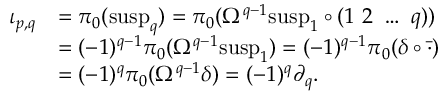Convert formula to latex. <formula><loc_0><loc_0><loc_500><loc_500>\begin{array} { r l } { \iota _ { p , q } } & { = \pi _ { 0 } ( s u s p _ { q } ) = \pi _ { 0 } ( \Omega ^ { q - 1 } s u s p _ { 1 } \circ ( 1 \ 2 \ \dots \ q ) ) } \\ & { = ( - 1 ) ^ { q - 1 } \pi _ { 0 } ( \Omega ^ { q - 1 } s u s p _ { 1 } ) = ( - 1 ) ^ { q - 1 } \pi _ { 0 } ( \delta \circ \ B a r { \cdot } ) } \\ & { = ( - 1 ) ^ { q } \pi _ { 0 } ( \Omega ^ { q - 1 } \delta ) = ( - 1 ) ^ { q } \partial _ { q } . } \end{array}</formula> 